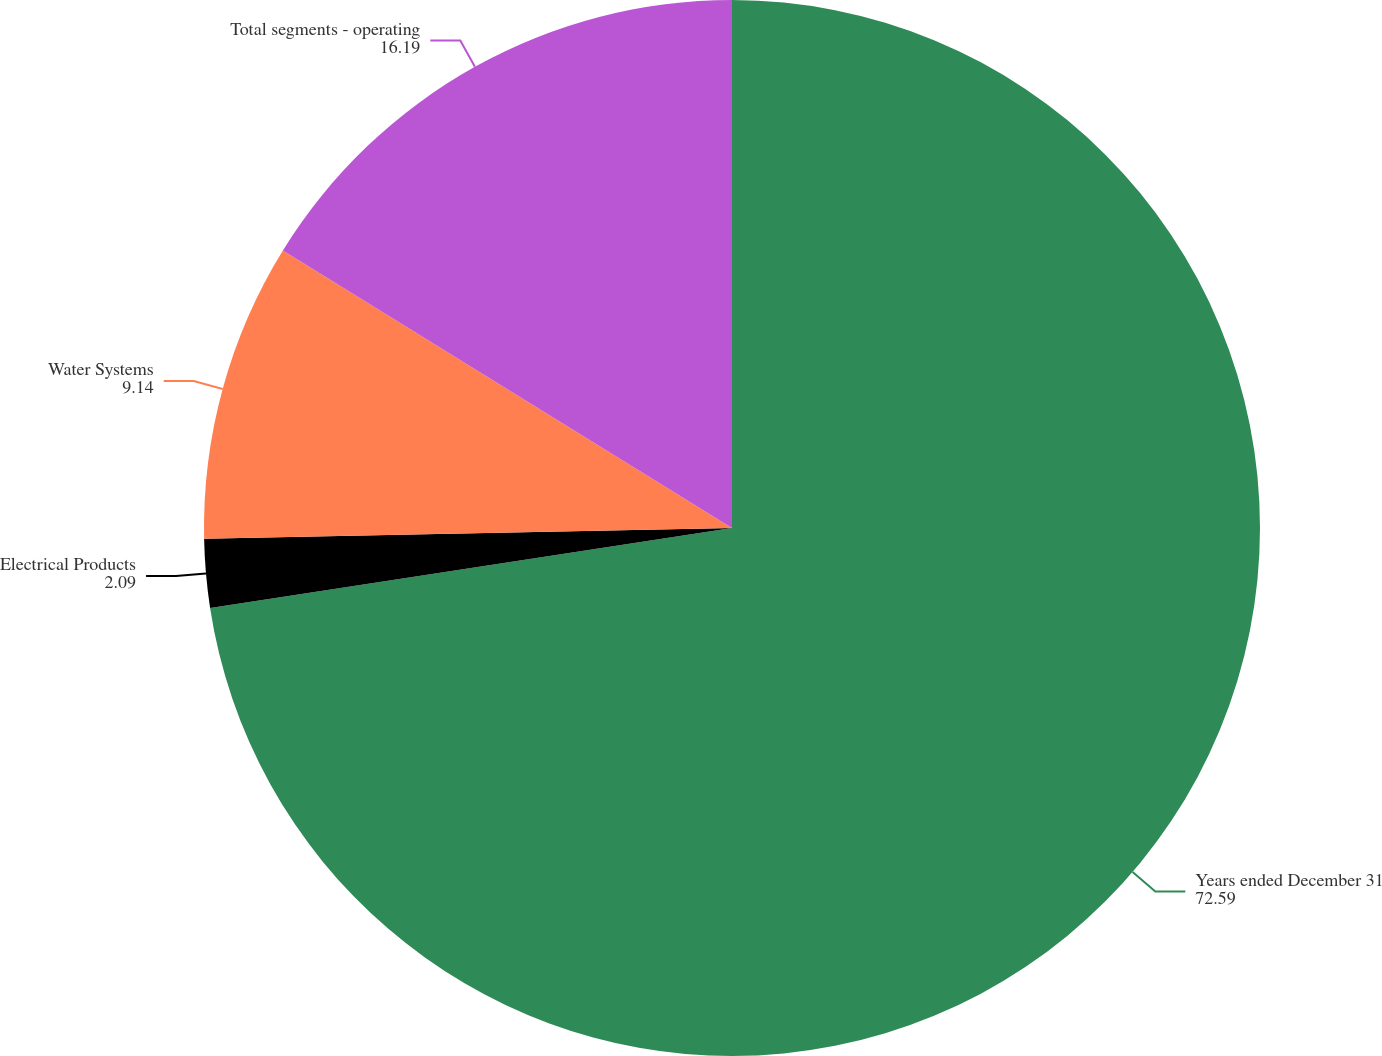Convert chart. <chart><loc_0><loc_0><loc_500><loc_500><pie_chart><fcel>Years ended December 31<fcel>Electrical Products<fcel>Water Systems<fcel>Total segments - operating<nl><fcel>72.59%<fcel>2.09%<fcel>9.14%<fcel>16.19%<nl></chart> 